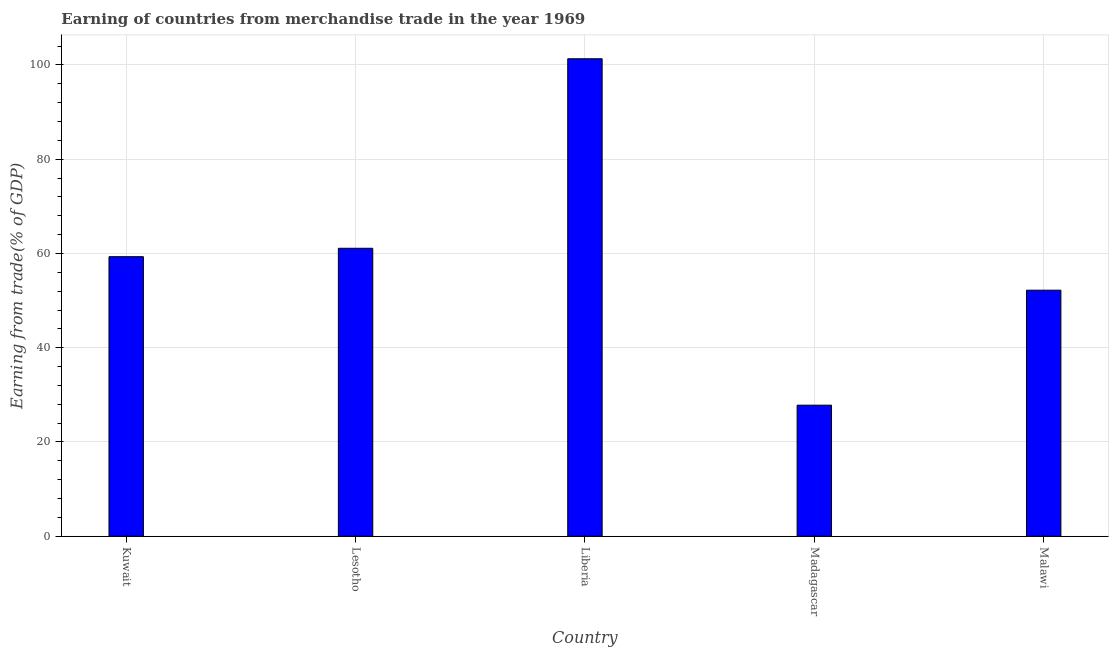What is the title of the graph?
Keep it short and to the point. Earning of countries from merchandise trade in the year 1969. What is the label or title of the Y-axis?
Provide a succinct answer. Earning from trade(% of GDP). What is the earning from merchandise trade in Kuwait?
Your response must be concise. 59.32. Across all countries, what is the maximum earning from merchandise trade?
Make the answer very short. 101.32. Across all countries, what is the minimum earning from merchandise trade?
Your answer should be very brief. 27.81. In which country was the earning from merchandise trade maximum?
Your answer should be very brief. Liberia. In which country was the earning from merchandise trade minimum?
Ensure brevity in your answer.  Madagascar. What is the sum of the earning from merchandise trade?
Ensure brevity in your answer.  301.75. What is the difference between the earning from merchandise trade in Kuwait and Madagascar?
Offer a very short reply. 31.51. What is the average earning from merchandise trade per country?
Give a very brief answer. 60.35. What is the median earning from merchandise trade?
Give a very brief answer. 59.32. What is the ratio of the earning from merchandise trade in Liberia to that in Madagascar?
Give a very brief answer. 3.64. Is the earning from merchandise trade in Liberia less than that in Malawi?
Offer a terse response. No. Is the difference between the earning from merchandise trade in Liberia and Madagascar greater than the difference between any two countries?
Provide a short and direct response. Yes. What is the difference between the highest and the second highest earning from merchandise trade?
Provide a succinct answer. 40.21. What is the difference between the highest and the lowest earning from merchandise trade?
Provide a short and direct response. 73.51. In how many countries, is the earning from merchandise trade greater than the average earning from merchandise trade taken over all countries?
Offer a terse response. 2. Are all the bars in the graph horizontal?
Offer a very short reply. No. What is the difference between two consecutive major ticks on the Y-axis?
Keep it short and to the point. 20. Are the values on the major ticks of Y-axis written in scientific E-notation?
Offer a very short reply. No. What is the Earning from trade(% of GDP) in Kuwait?
Offer a terse response. 59.32. What is the Earning from trade(% of GDP) of Lesotho?
Make the answer very short. 61.1. What is the Earning from trade(% of GDP) of Liberia?
Offer a terse response. 101.32. What is the Earning from trade(% of GDP) in Madagascar?
Offer a terse response. 27.81. What is the Earning from trade(% of GDP) in Malawi?
Ensure brevity in your answer.  52.21. What is the difference between the Earning from trade(% of GDP) in Kuwait and Lesotho?
Provide a short and direct response. -1.78. What is the difference between the Earning from trade(% of GDP) in Kuwait and Liberia?
Keep it short and to the point. -42. What is the difference between the Earning from trade(% of GDP) in Kuwait and Madagascar?
Your response must be concise. 31.51. What is the difference between the Earning from trade(% of GDP) in Kuwait and Malawi?
Give a very brief answer. 7.11. What is the difference between the Earning from trade(% of GDP) in Lesotho and Liberia?
Your response must be concise. -40.21. What is the difference between the Earning from trade(% of GDP) in Lesotho and Madagascar?
Offer a very short reply. 33.29. What is the difference between the Earning from trade(% of GDP) in Lesotho and Malawi?
Offer a terse response. 8.89. What is the difference between the Earning from trade(% of GDP) in Liberia and Madagascar?
Your response must be concise. 73.51. What is the difference between the Earning from trade(% of GDP) in Liberia and Malawi?
Your response must be concise. 49.11. What is the difference between the Earning from trade(% of GDP) in Madagascar and Malawi?
Give a very brief answer. -24.4. What is the ratio of the Earning from trade(% of GDP) in Kuwait to that in Liberia?
Make the answer very short. 0.58. What is the ratio of the Earning from trade(% of GDP) in Kuwait to that in Madagascar?
Provide a succinct answer. 2.13. What is the ratio of the Earning from trade(% of GDP) in Kuwait to that in Malawi?
Provide a succinct answer. 1.14. What is the ratio of the Earning from trade(% of GDP) in Lesotho to that in Liberia?
Your answer should be very brief. 0.6. What is the ratio of the Earning from trade(% of GDP) in Lesotho to that in Madagascar?
Offer a very short reply. 2.2. What is the ratio of the Earning from trade(% of GDP) in Lesotho to that in Malawi?
Keep it short and to the point. 1.17. What is the ratio of the Earning from trade(% of GDP) in Liberia to that in Madagascar?
Your answer should be very brief. 3.64. What is the ratio of the Earning from trade(% of GDP) in Liberia to that in Malawi?
Your answer should be very brief. 1.94. What is the ratio of the Earning from trade(% of GDP) in Madagascar to that in Malawi?
Provide a short and direct response. 0.53. 